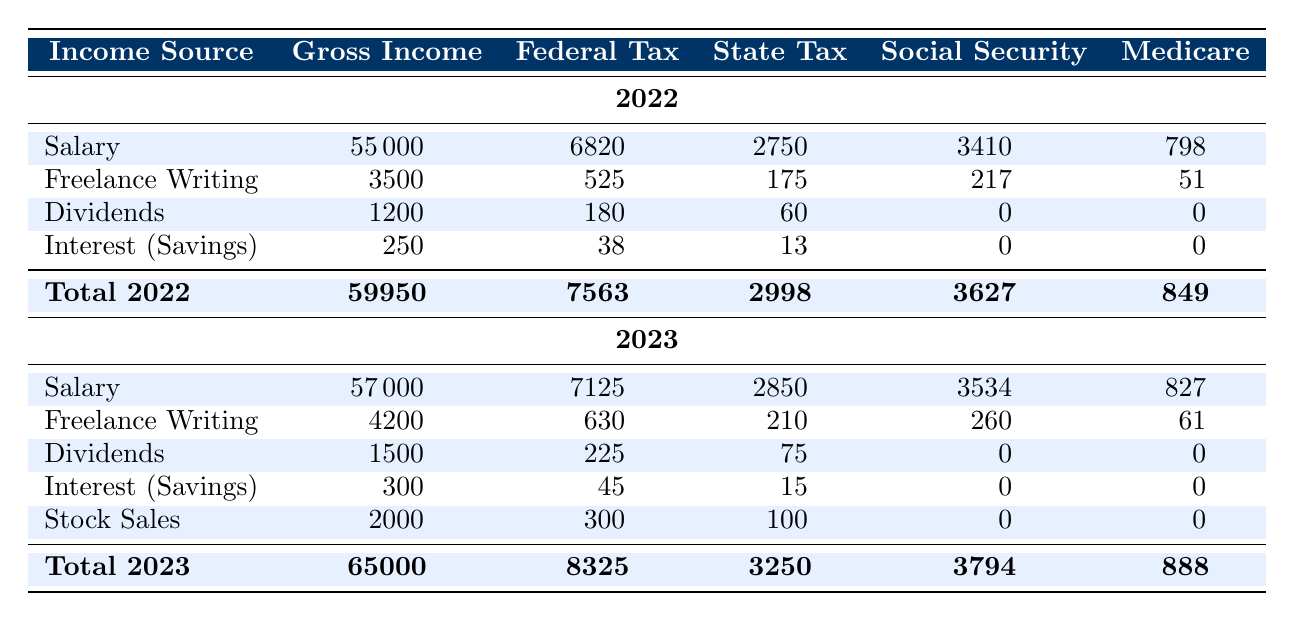What is the total gross income reported for the year 2022? To find the total gross income for 2022, we add the gross incomes for all income sources in that year: 55000 + 3500 + 1200 + 250 = 59950.
Answer: 59950 What is the federal tax paid for salary in 2023? The table shows that the federal tax paid for salary in 2023 is 7125.
Answer: 7125 Was the federal tax for freelance writing higher in 2022 than in 2023? The federal tax for freelance writing in 2022 was 525, while in 2023 it was 630, which is higher.
Answer: Yes What is the average state tax paid across all income sources for the year 2023? The state tax amounts for 2023 are: 2850 (Salary) + 210 (Freelance Writing) + 75 (Dividends) + 15 (Interest) + 100 (Stock Sales) = 3250. There are 5 income sources, so the average state tax is 3250/5 = 650.
Answer: 650 How much more social security tax was paid in 2023 compared to 2022? In 2022, the total social security tax was 3410 + 217 + 0 + 0 = 3627. In 2023, it is 3534 + 260 + 0 + 0 = 3794. The difference is 3794 - 3627 = 167.
Answer: 167 What is the total Medicare tax paid in 2022? The Medicare tax for 2022 includes: 798 (Salary) + 51 (Freelance Writing) + 0 (Dividends) + 0 (Interest) = 849.
Answer: 849 Was the total gross income for 2023 higher than that for 2022? The total gross income for 2022 is 59950, and for 2023 it is 65000. Since 65000 is greater than 59950, the total gross income for 2023 is higher.
Answer: Yes What is the gross income of dividends for 2022? The table indicates that the gross income for dividends in 2022 is 1200.
Answer: 1200 What is the difference in total federal tax between 2022 and 2023? The total federal tax for 2022 is 7563, and for 2023 it is 8325. The difference is 8325 - 7563 = 762.
Answer: 762 